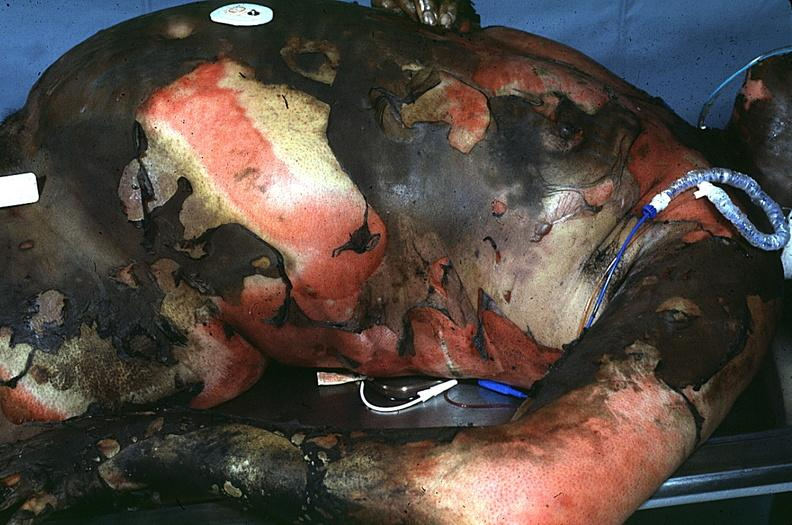does this image show thermal burn?
Answer the question using a single word or phrase. Yes 